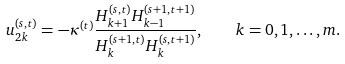<formula> <loc_0><loc_0><loc_500><loc_500>u _ { 2 k } ^ { ( s , t ) } = - \kappa ^ { ( t ) } \frac { H _ { k + 1 } ^ { ( s , t ) } H _ { k - 1 } ^ { ( s + 1 , t + 1 ) } } { H _ { k } ^ { ( s + 1 , t ) } H _ { k } ^ { ( s , t + 1 ) } } , \quad k = 0 , 1 , \dots , m .</formula> 